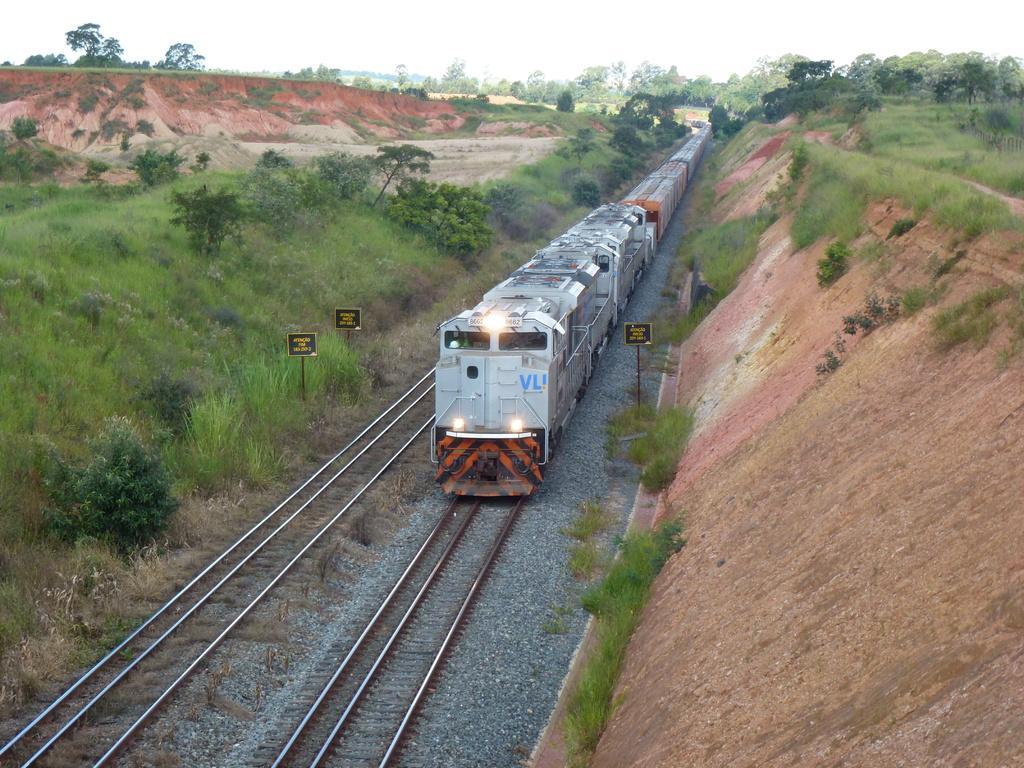Can you describe this image briefly? In this picture there is a train in the center of the image, on the tracks and there are poles in the image and there is greenery in the image. 